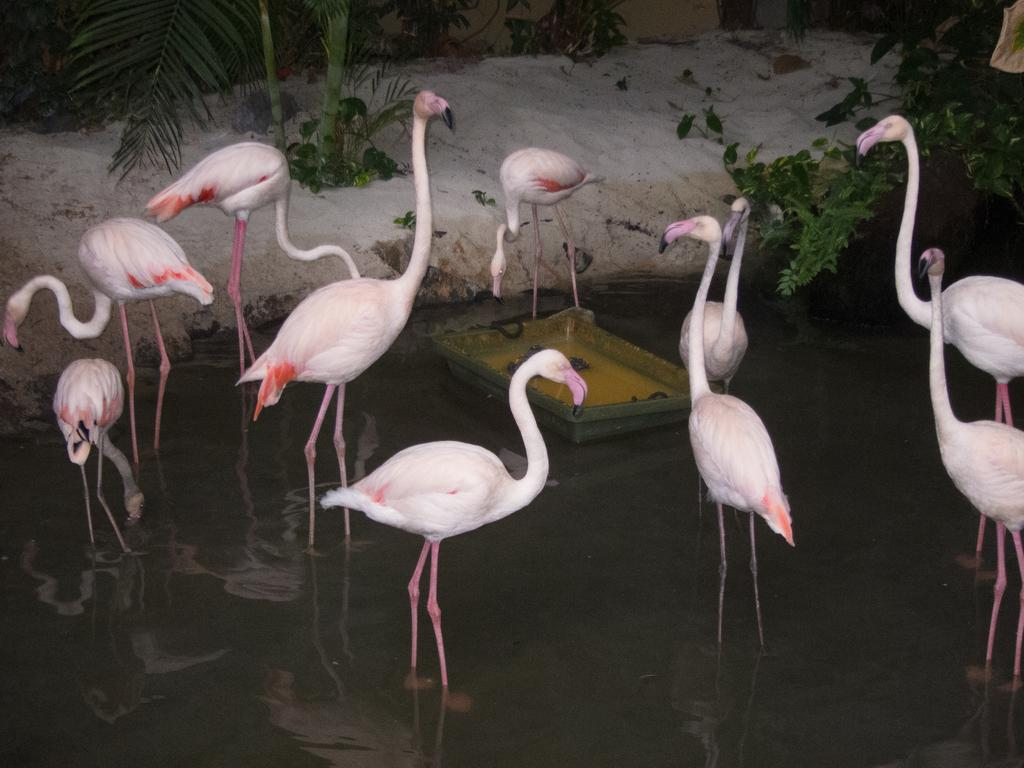What animals can be seen in the water in the image? There is a group of birds in the water in the image. What is located in the center of the image? There is a tub in the center of the image. What can be seen in the background of the image? Plants and leaves are visible in the background. How does the distribution of breathable air affect the birds in the image? There is no information about the distribution of breathable air in the image, and therefore its effect on the birds cannot be determined. 